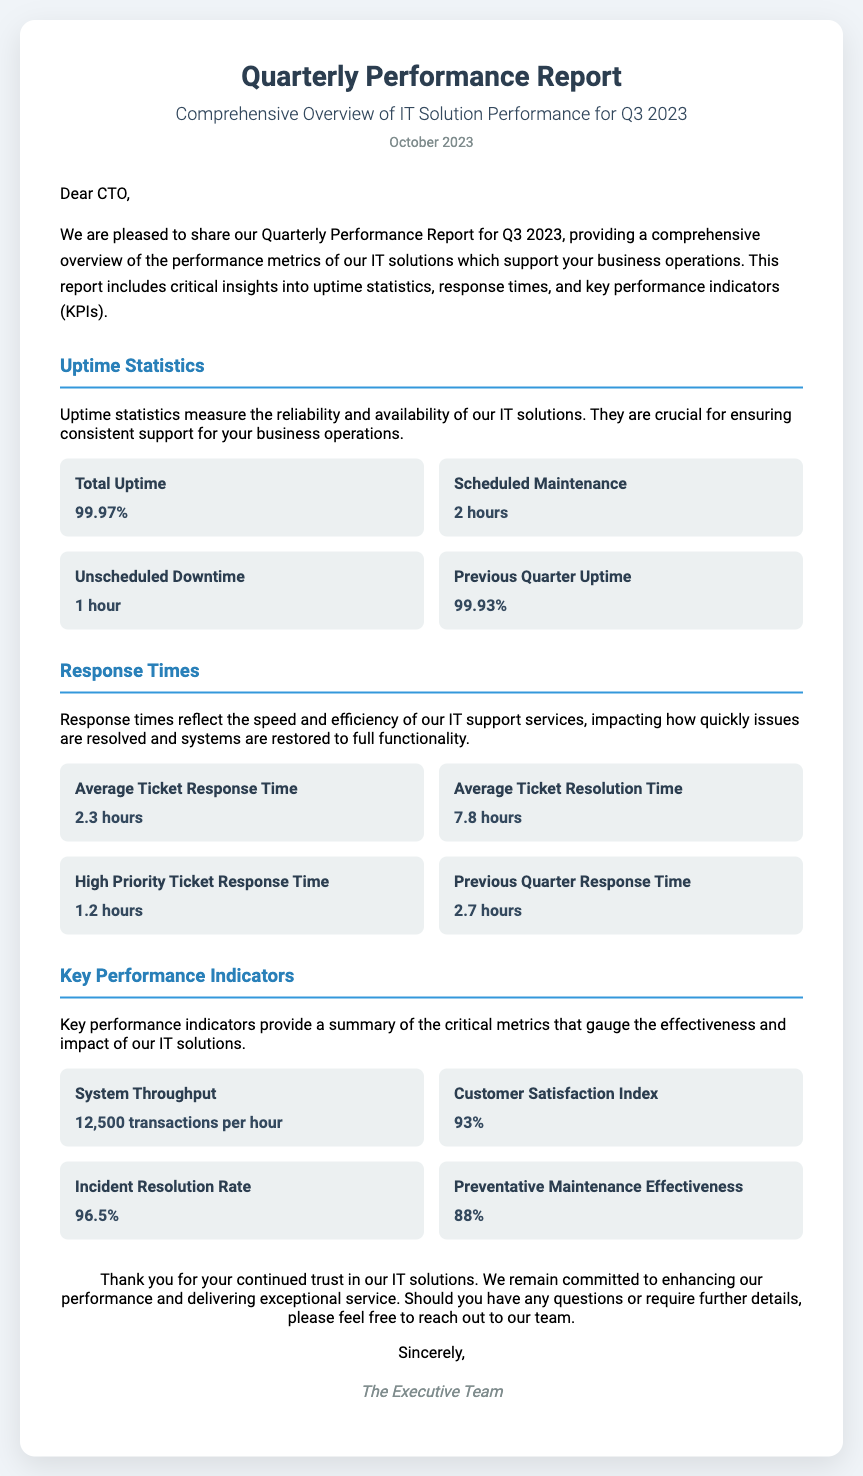What is the total uptime for Q3 2023? The total uptime is stated clearly in the document under uptime statistics.
Answer: 99.97% How many hours of unscheduled downtime were recorded? The document specifies the unscheduled downtime in the same section as the total uptime.
Answer: 1 hour What is the average ticket response time? The average ticket response time is mentioned in the response times section of the report.
Answer: 2.3 hours What was the previous quarter's uptime percentage? This information can be found in the uptime statistics section comparing quarters.
Answer: 99.93% What is the customer satisfaction index? The customer satisfaction index is one of the key performance indicators outlined in the report.
Answer: 93% Which performance metric experienced the most improvement from the previous quarter? Reasoning from both the previous and current quarters will indicate which metric improved the most.
Answer: Uptime What is the total system throughput measured in transactions? The throughput is explicitly detailed in the key performance indicators section of the report.
Answer: 12,500 transactions per hour What is the effectiveness percentage of preventative maintenance? The effectiveness of preventative maintenance is provided in the key performance indicators section.
Answer: 88% How many hours were allocated for scheduled maintenance? The scheduled maintenance duration is specified in the uptime statistics section.
Answer: 2 hours 